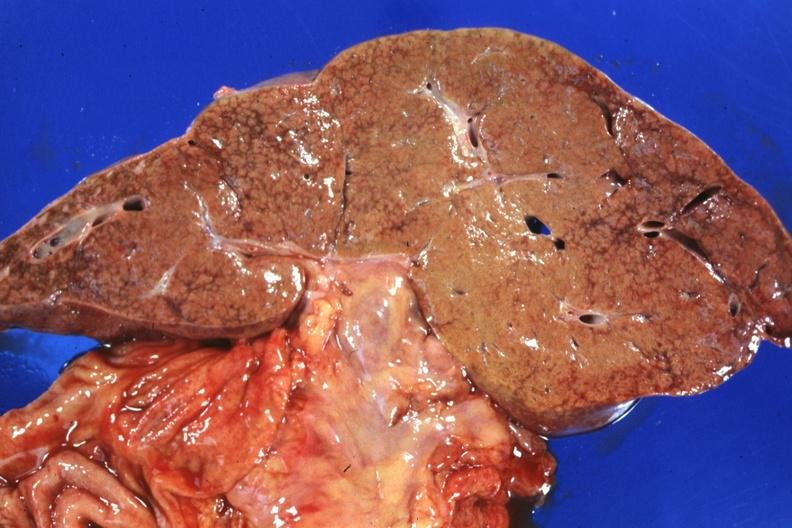s natural color present?
Answer the question using a single word or phrase. No 